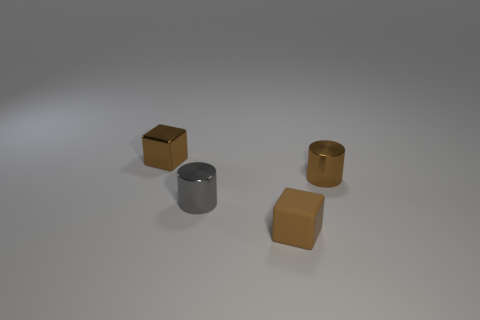Which of these objects is the lightest in color? The cylindrical block is the lightest in color, displaying a silver tone that reflects a significant amount of light compared to the other objects. 